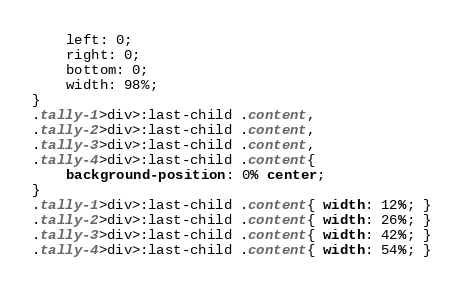Convert code to text. <code><loc_0><loc_0><loc_500><loc_500><_CSS_>	left: 0;
	right: 0;
	bottom: 0;
	width: 98%;
}
.tally-1>div>:last-child .content,
.tally-2>div>:last-child .content,
.tally-3>div>:last-child .content,
.tally-4>div>:last-child .content{
	background-position: 0% center;
}
.tally-1>div>:last-child .content{ width: 12%; }
.tally-2>div>:last-child .content{ width: 26%; }
.tally-3>div>:last-child .content{ width: 42%; }
.tally-4>div>:last-child .content{ width: 54%; }
</code> 